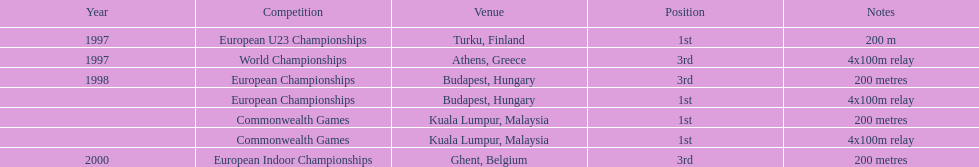Identify the alternative competitions, besides the european u23 championship, where the 1st position was secured. European Championships, Commonwealth Games, Commonwealth Games. I'm looking to parse the entire table for insights. Could you assist me with that? {'header': ['Year', 'Competition', 'Venue', 'Position', 'Notes'], 'rows': [['1997', 'European U23 Championships', 'Turku, Finland', '1st', '200 m'], ['1997', 'World Championships', 'Athens, Greece', '3rd', '4x100m relay'], ['1998', 'European Championships', 'Budapest, Hungary', '3rd', '200 metres'], ['', 'European Championships', 'Budapest, Hungary', '1st', '4x100m relay'], ['', 'Commonwealth Games', 'Kuala Lumpur, Malaysia', '1st', '200 metres'], ['', 'Commonwealth Games', 'Kuala Lumpur, Malaysia', '1st', '4x100m relay'], ['2000', 'European Indoor Championships', 'Ghent, Belgium', '3rd', '200 metres']]} 